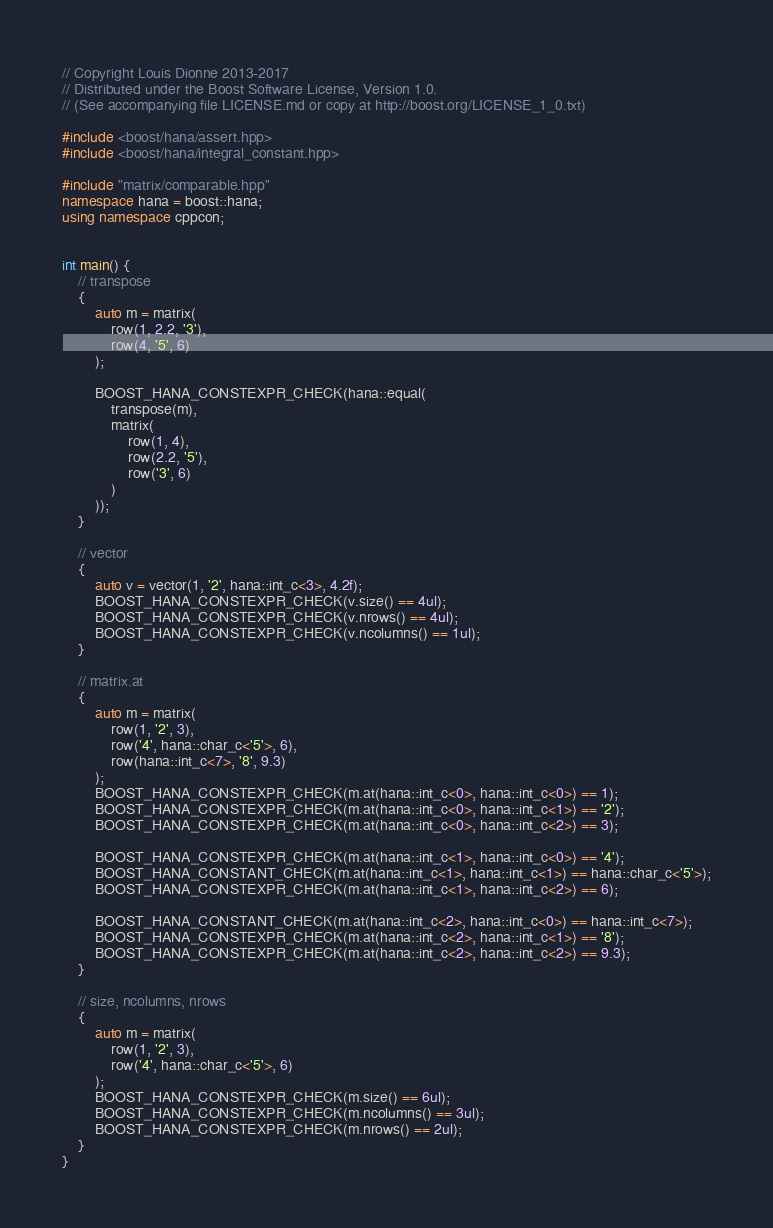<code> <loc_0><loc_0><loc_500><loc_500><_C++_>// Copyright Louis Dionne 2013-2017
// Distributed under the Boost Software License, Version 1.0.
// (See accompanying file LICENSE.md or copy at http://boost.org/LICENSE_1_0.txt)

#include <boost/hana/assert.hpp>
#include <boost/hana/integral_constant.hpp>

#include "matrix/comparable.hpp"
namespace hana = boost::hana;
using namespace cppcon;


int main() {
    // transpose
    {
        auto m = matrix(
            row(1, 2.2, '3'),
            row(4, '5', 6)
        );

        BOOST_HANA_CONSTEXPR_CHECK(hana::equal(
            transpose(m),
            matrix(
                row(1, 4),
                row(2.2, '5'),
                row('3', 6)
            )
        ));
    }

    // vector
    {
        auto v = vector(1, '2', hana::int_c<3>, 4.2f);
        BOOST_HANA_CONSTEXPR_CHECK(v.size() == 4ul);
        BOOST_HANA_CONSTEXPR_CHECK(v.nrows() == 4ul);
        BOOST_HANA_CONSTEXPR_CHECK(v.ncolumns() == 1ul);
    }

    // matrix.at
    {
        auto m = matrix(
            row(1, '2', 3),
            row('4', hana::char_c<'5'>, 6),
            row(hana::int_c<7>, '8', 9.3)
        );
        BOOST_HANA_CONSTEXPR_CHECK(m.at(hana::int_c<0>, hana::int_c<0>) == 1);
        BOOST_HANA_CONSTEXPR_CHECK(m.at(hana::int_c<0>, hana::int_c<1>) == '2');
        BOOST_HANA_CONSTEXPR_CHECK(m.at(hana::int_c<0>, hana::int_c<2>) == 3);

        BOOST_HANA_CONSTEXPR_CHECK(m.at(hana::int_c<1>, hana::int_c<0>) == '4');
        BOOST_HANA_CONSTANT_CHECK(m.at(hana::int_c<1>, hana::int_c<1>) == hana::char_c<'5'>);
        BOOST_HANA_CONSTEXPR_CHECK(m.at(hana::int_c<1>, hana::int_c<2>) == 6);

        BOOST_HANA_CONSTANT_CHECK(m.at(hana::int_c<2>, hana::int_c<0>) == hana::int_c<7>);
        BOOST_HANA_CONSTEXPR_CHECK(m.at(hana::int_c<2>, hana::int_c<1>) == '8');
        BOOST_HANA_CONSTEXPR_CHECK(m.at(hana::int_c<2>, hana::int_c<2>) == 9.3);
    }

    // size, ncolumns, nrows
    {
        auto m = matrix(
            row(1, '2', 3),
            row('4', hana::char_c<'5'>, 6)
        );
        BOOST_HANA_CONSTEXPR_CHECK(m.size() == 6ul);
        BOOST_HANA_CONSTEXPR_CHECK(m.ncolumns() == 3ul);
        BOOST_HANA_CONSTEXPR_CHECK(m.nrows() == 2ul);
    }
}
</code> 